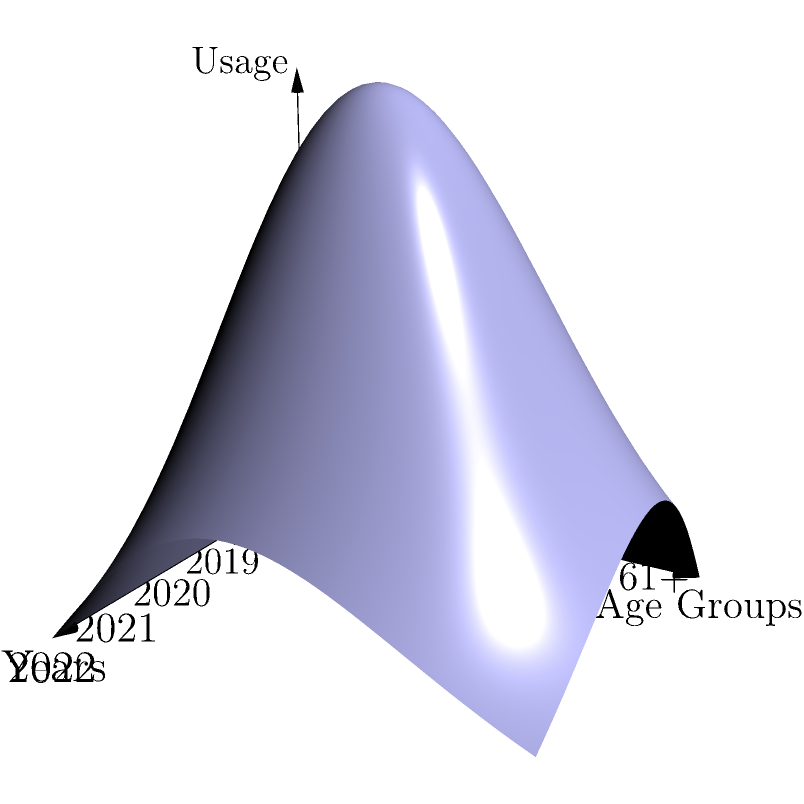The 3D graph shows the health benefit usage trends across different age groups over the past five years. Which age group consistently demonstrates the highest usage percentage, and what pattern can be observed in their usage trend over time? To answer this question, we need to analyze the 3D graph carefully:

1. The x-axis represents years from 2018 to 2022.
2. The y-axis represents age groups from 20-30 to 61+.
3. The z-axis represents the usage percentage.

Step 1: Identify the highest peak on the graph.
The highest peak appears to be in the 61+ age group (the furthest y-axis value).

Step 2: Observe the trend for the 61+ age group across years.
The usage percentage for the 61+ group starts relatively high in 2018, increases slightly in 2019, peaks in 2020, and then shows a gradual decline in 2021 and 2022.

Step 3: Compare the 61+ group's trend to other age groups.
While other age groups show some fluctuations, none consistently reach the height of the 61+ group's usage percentage.

Step 4: Interpret the pattern.
The 61+ age group shows a bell-shaped trend over time, with a peak in 2020. This could be attributed to increased healthcare needs during the COVID-19 pandemic, particularly for older employees.
Answer: 61+ group; bell-shaped trend peaking in 2020 